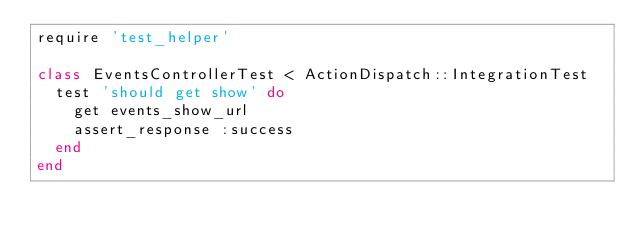Convert code to text. <code><loc_0><loc_0><loc_500><loc_500><_Ruby_>require 'test_helper'

class EventsControllerTest < ActionDispatch::IntegrationTest
  test 'should get show' do
    get events_show_url
    assert_response :success
  end
end
</code> 